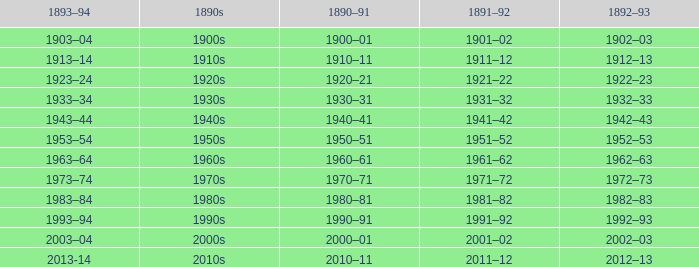What is the year from 1891-92 from the years 1890s to the 1960s? 1961–62. 